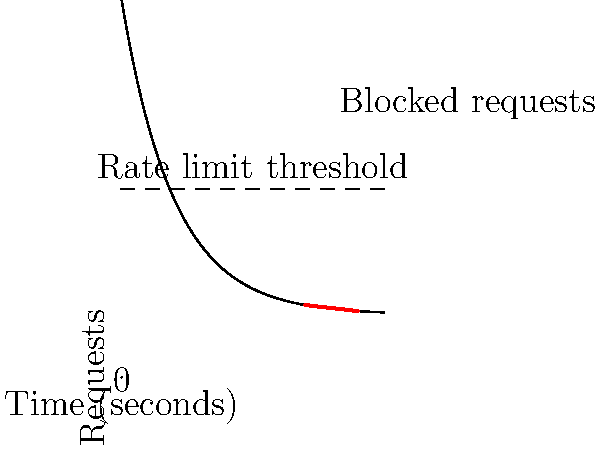Based on the graph showing a rate-limiting mechanism for preventing brute force attacks, what strategy should be implemented to effectively block suspicious activity while minimizing impact on legitimate users? To effectively implement a rate-limiting mechanism for preventing brute force attacks, we need to analyze the graph and consider the following steps:

1. Observe the curve: The graph shows an exponential decay of request frequency over time, which is typical for both legitimate users and potential attackers.

2. Identify the rate limit threshold: The dashed line represents the maximum allowed request rate. Requests above this line are considered suspicious.

3. Notice the blocked requests: The red line segment indicates requests that exceed the threshold and are blocked.

4. Consider the trade-off: Setting the threshold too low might affect legitimate users, while setting it too high might allow attacks to slip through.

5. Implement a sliding window: Instead of using a fixed time window, use a sliding window approach to track requests over time. This allows for more accurate detection of sudden spikes in activity.

6. Use exponential back-off: When a client exceeds the rate limit, increase the waiting time exponentially for subsequent requests. This helps to quickly throttle potential attacks while allowing legitimate users to recover.

7. Implement IP-based and account-based rate limiting: Combine both methods to prevent attackers from bypassing the system by using multiple IP addresses or accounts.

8. Add CAPTCHA or additional authentication: When the rate limit is approached, introduce additional verification steps to distinguish between humans and bots.

9. Monitor and adjust: Regularly analyze logs and adjust the rate limit threshold based on observed patterns of legitimate use and attack attempts.

10. Implement fail2ban or similar tools: Use automated tools to temporarily ban IP addresses that show suspicious activity patterns.

By implementing these strategies, we can create a robust rate-limiting mechanism that effectively blocks brute force attacks while minimizing the impact on legitimate users.
Answer: Implement sliding window rate limiting with exponential back-off, combined IP and account-based limits, and adaptive thresholds. 